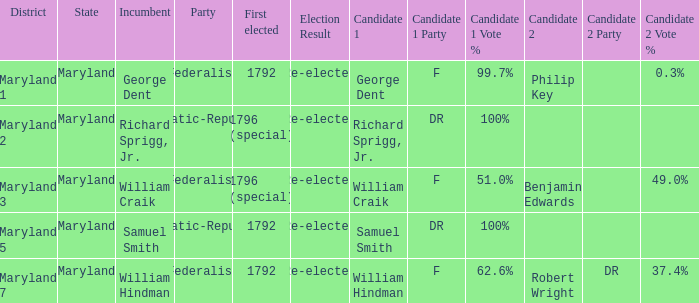What is the verdict for maryland district 7? Re-elected. 